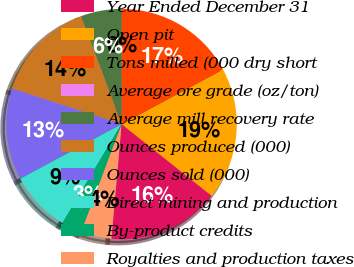Convert chart to OTSL. <chart><loc_0><loc_0><loc_500><loc_500><pie_chart><fcel>Year Ended December 31<fcel>Open pit<fcel>Tons milled (000 dry short<fcel>Average ore grade (oz/ton)<fcel>Average mill recovery rate<fcel>Ounces produced (000)<fcel>Ounces sold (000)<fcel>Direct mining and production<fcel>By-product credits<fcel>Royalties and production taxes<nl><fcel>15.71%<fcel>18.57%<fcel>17.14%<fcel>0.0%<fcel>5.71%<fcel>14.29%<fcel>12.86%<fcel>8.57%<fcel>2.86%<fcel>4.29%<nl></chart> 